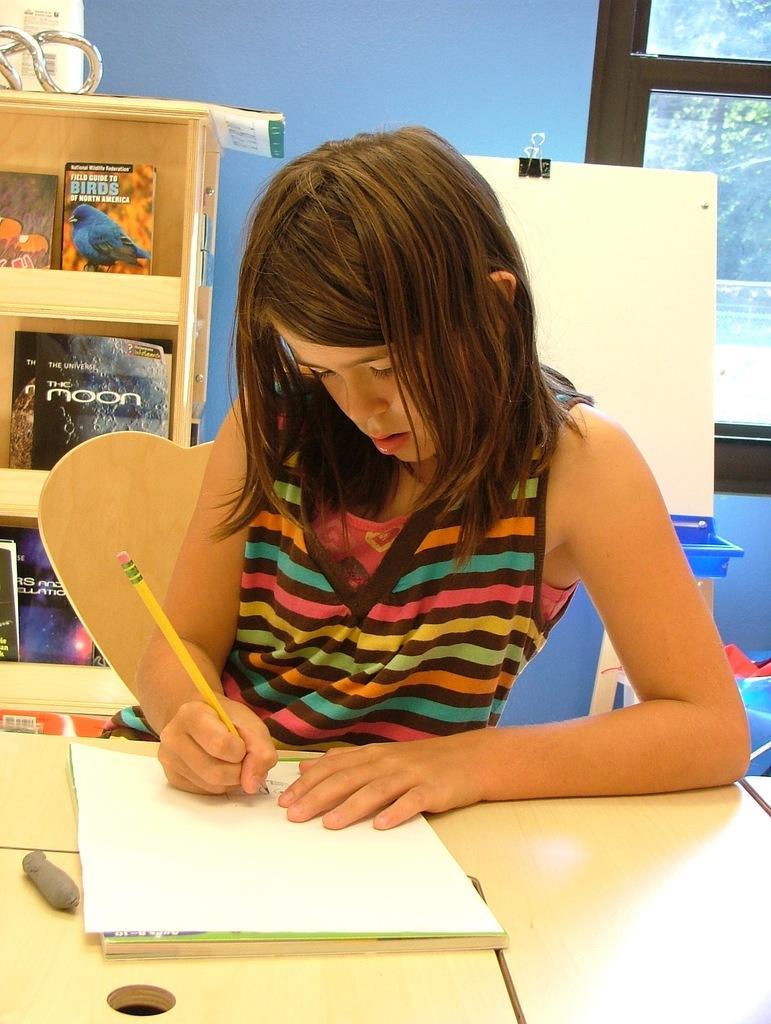Describe this image in one or two sentences. This picture shows a girl seated on the chair and writing on a paper with a pencil and we see a table and a bookshelf back of her 